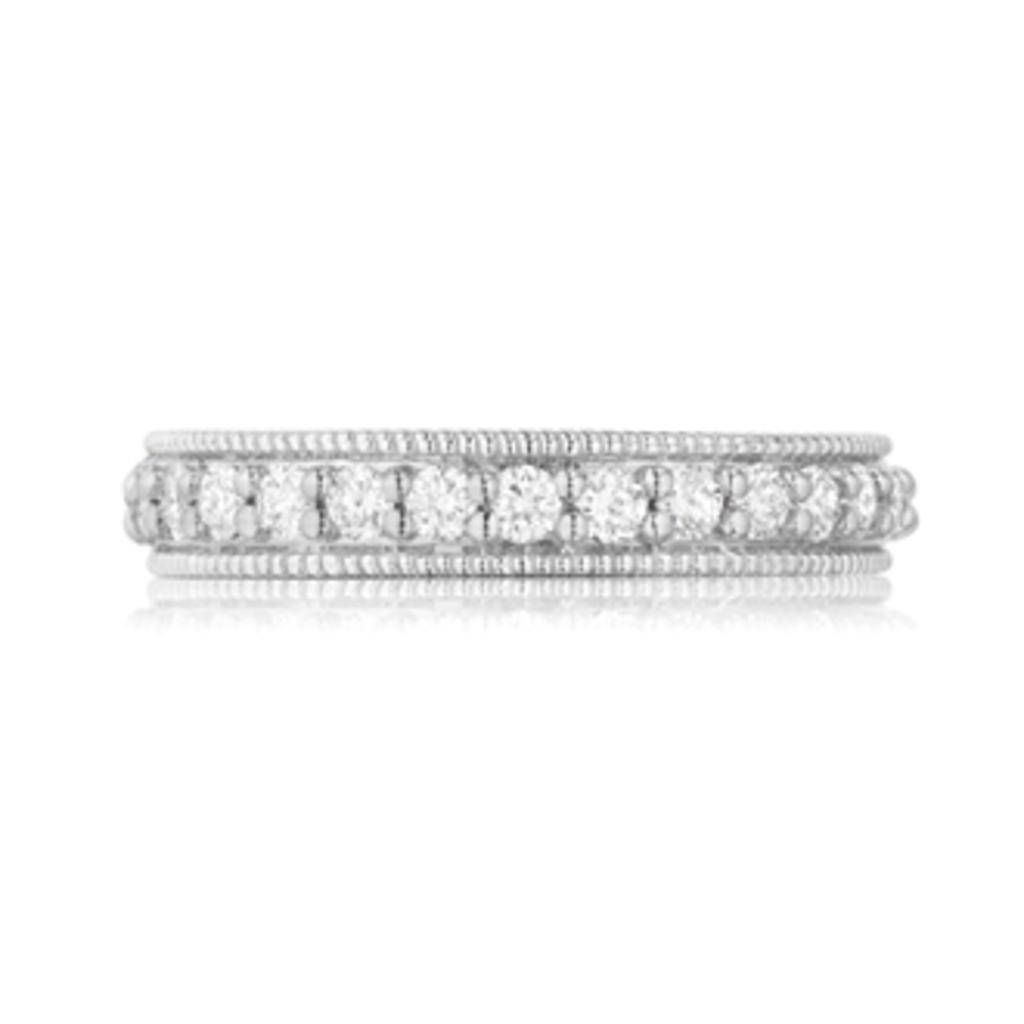What is the main object in the image? There is a bangle in the image. What color is the background of the image? The background of the image is white. How many trees are visible in the image? There are no trees visible in the image, as it only features a bangle against a white background. 